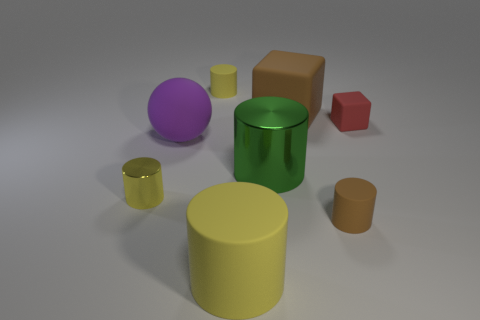What size is the matte cylinder that is the same color as the large rubber block?
Offer a very short reply. Small. What size is the other yellow metal thing that is the same shape as the big yellow thing?
Offer a terse response. Small. What is the size of the yellow object that is both behind the small brown object and on the right side of the tiny yellow shiny cylinder?
Provide a short and direct response. Small. Is the shape of the green metal object the same as the tiny yellow object right of the big purple rubber thing?
Give a very brief answer. Yes. What number of things are either cubes on the right side of the large brown thing or brown things?
Provide a short and direct response. 3. Is the material of the large yellow object the same as the tiny yellow cylinder that is behind the small red rubber object?
Provide a short and direct response. Yes. There is a tiny yellow object that is in front of the big brown matte cube that is behind the brown matte cylinder; what shape is it?
Give a very brief answer. Cylinder. There is a tiny metal object; does it have the same color as the big cylinder that is to the left of the large green metal thing?
Ensure brevity in your answer.  Yes. Are there any other things that are made of the same material as the big brown cube?
Provide a short and direct response. Yes. The large green object is what shape?
Provide a short and direct response. Cylinder. 